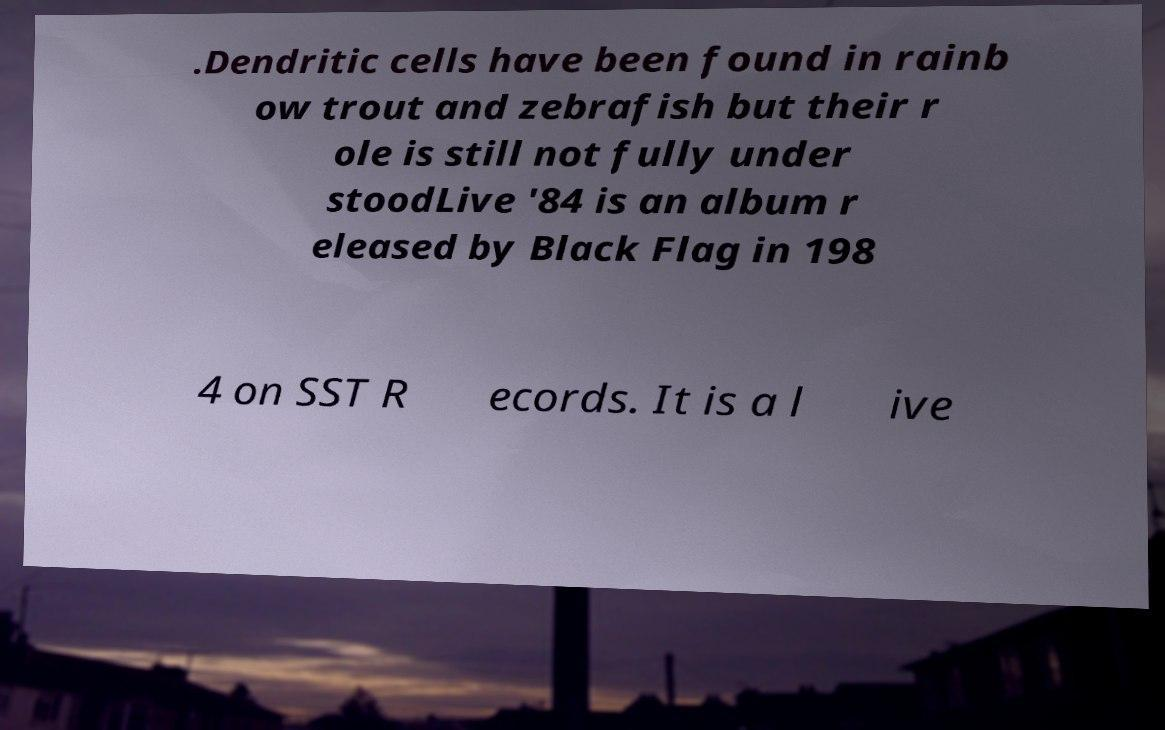I need the written content from this picture converted into text. Can you do that? .Dendritic cells have been found in rainb ow trout and zebrafish but their r ole is still not fully under stoodLive '84 is an album r eleased by Black Flag in 198 4 on SST R ecords. It is a l ive 